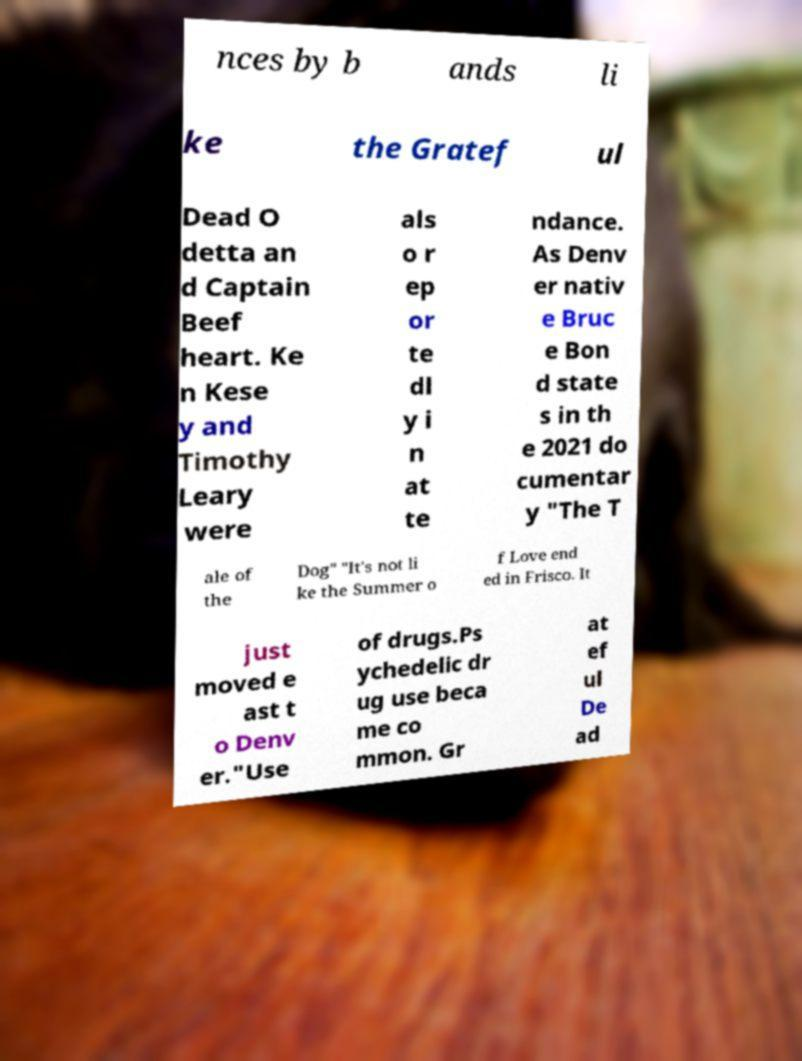What messages or text are displayed in this image? I need them in a readable, typed format. nces by b ands li ke the Gratef ul Dead O detta an d Captain Beef heart. Ke n Kese y and Timothy Leary were als o r ep or te dl y i n at te ndance. As Denv er nativ e Bruc e Bon d state s in th e 2021 do cumentar y "The T ale of the Dog" "It's not li ke the Summer o f Love end ed in Frisco. It just moved e ast t o Denv er."Use of drugs.Ps ychedelic dr ug use beca me co mmon. Gr at ef ul De ad 